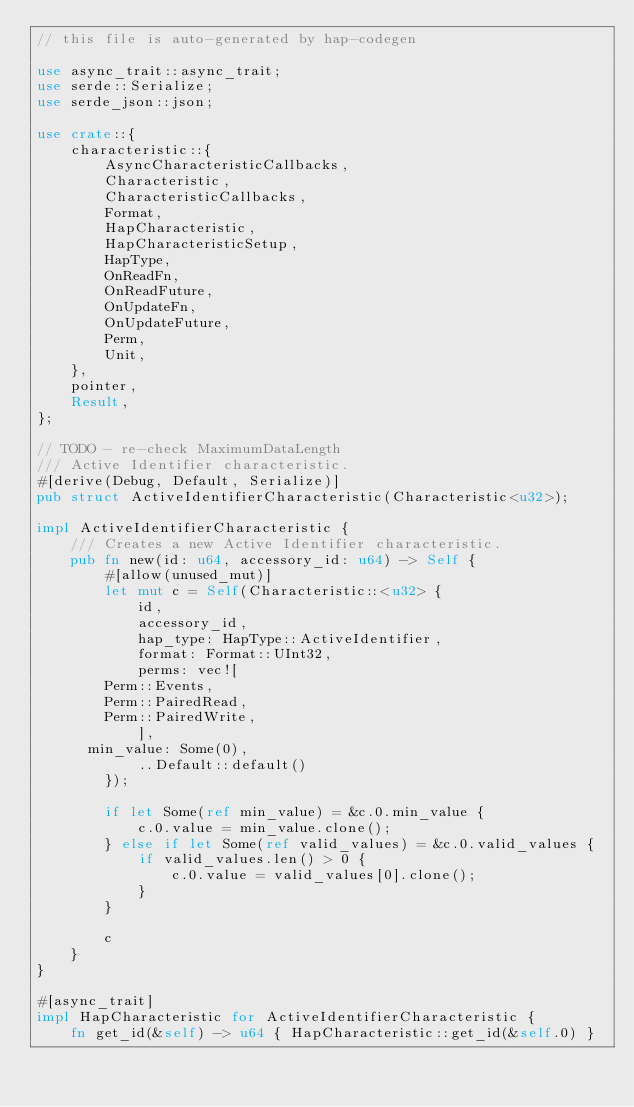Convert code to text. <code><loc_0><loc_0><loc_500><loc_500><_Rust_>// this file is auto-generated by hap-codegen

use async_trait::async_trait;
use serde::Serialize;
use serde_json::json;

use crate::{
    characteristic::{
        AsyncCharacteristicCallbacks,
        Characteristic,
        CharacteristicCallbacks,
        Format,
        HapCharacteristic,
        HapCharacteristicSetup,
        HapType,
        OnReadFn,
        OnReadFuture,
        OnUpdateFn,
        OnUpdateFuture,
        Perm,
        Unit,
    },
    pointer,
    Result,
};

// TODO - re-check MaximumDataLength
/// Active Identifier characteristic.
#[derive(Debug, Default, Serialize)]
pub struct ActiveIdentifierCharacteristic(Characteristic<u32>);

impl ActiveIdentifierCharacteristic {
    /// Creates a new Active Identifier characteristic.
    pub fn new(id: u64, accessory_id: u64) -> Self {
        #[allow(unused_mut)]
        let mut c = Self(Characteristic::<u32> {
            id,
            accessory_id,
            hap_type: HapType::ActiveIdentifier,
            format: Format::UInt32,
            perms: vec![
				Perm::Events,
				Perm::PairedRead,
				Perm::PairedWrite,
            ],
			min_value: Some(0),
            ..Default::default()
        });

        if let Some(ref min_value) = &c.0.min_value {
            c.0.value = min_value.clone();
        } else if let Some(ref valid_values) = &c.0.valid_values {
            if valid_values.len() > 0 {
                c.0.value = valid_values[0].clone();
            }
        }

        c
    }
}

#[async_trait]
impl HapCharacteristic for ActiveIdentifierCharacteristic {
    fn get_id(&self) -> u64 { HapCharacteristic::get_id(&self.0) }
</code> 